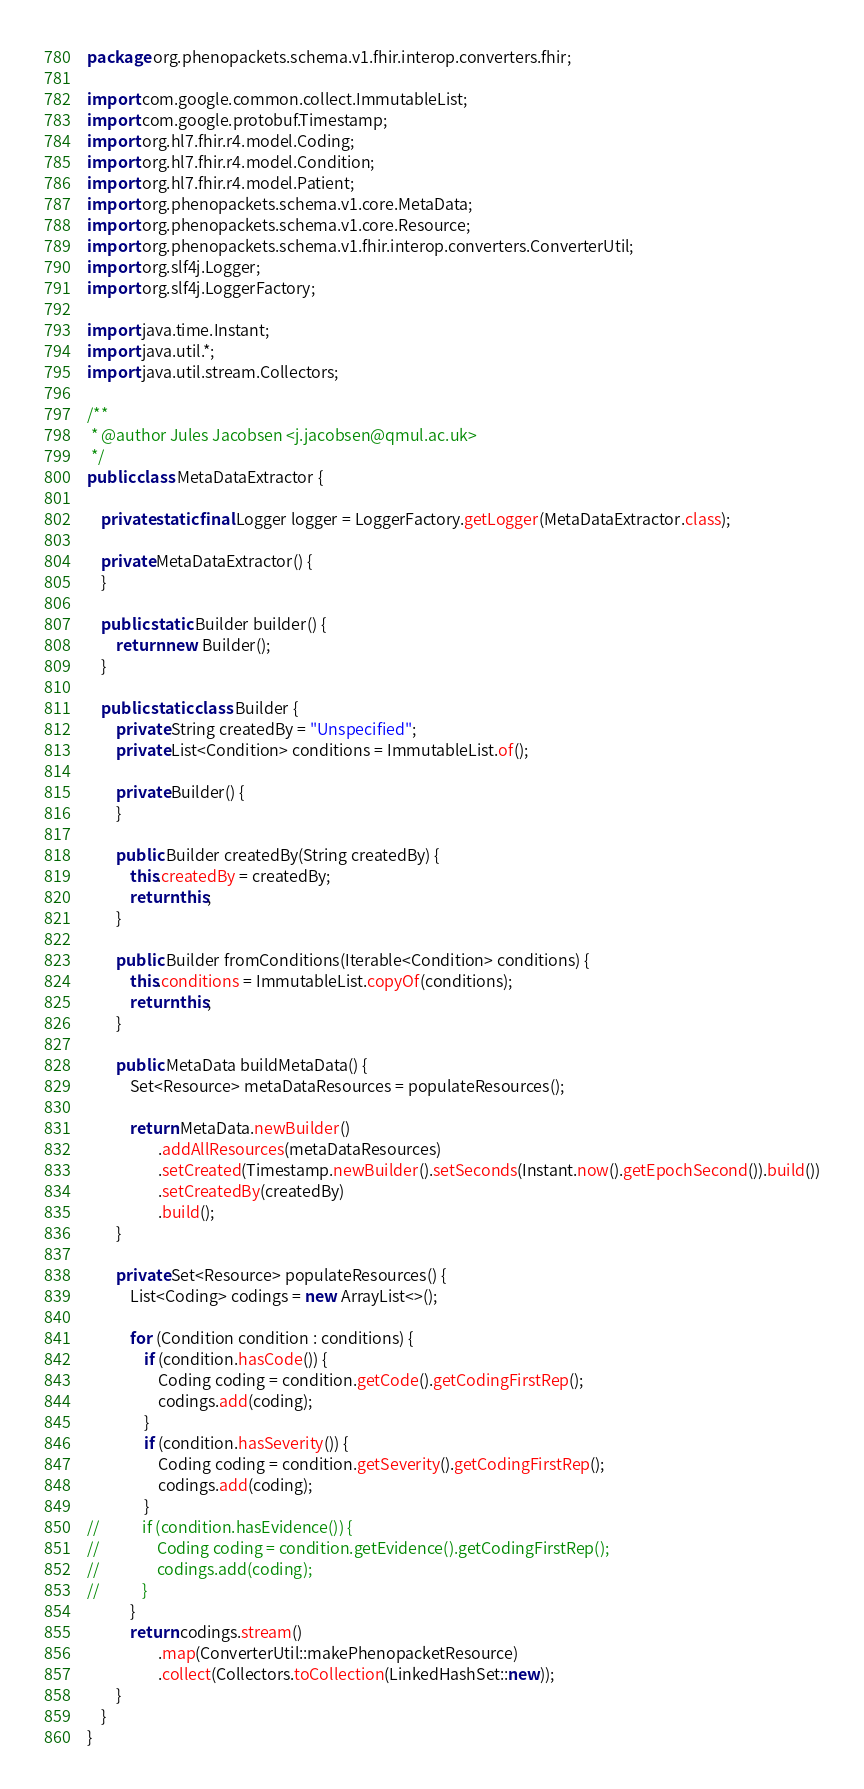<code> <loc_0><loc_0><loc_500><loc_500><_Java_>package org.phenopackets.schema.v1.fhir.interop.converters.fhir;

import com.google.common.collect.ImmutableList;
import com.google.protobuf.Timestamp;
import org.hl7.fhir.r4.model.Coding;
import org.hl7.fhir.r4.model.Condition;
import org.hl7.fhir.r4.model.Patient;
import org.phenopackets.schema.v1.core.MetaData;
import org.phenopackets.schema.v1.core.Resource;
import org.phenopackets.schema.v1.fhir.interop.converters.ConverterUtil;
import org.slf4j.Logger;
import org.slf4j.LoggerFactory;

import java.time.Instant;
import java.util.*;
import java.util.stream.Collectors;

/**
 * @author Jules Jacobsen <j.jacobsen@qmul.ac.uk>
 */
public class MetaDataExtractor {

    private static final Logger logger = LoggerFactory.getLogger(MetaDataExtractor.class);

    private MetaDataExtractor() {
    }

    public static Builder builder() {
        return new Builder();
    }

    public static class Builder {
        private String createdBy = "Unspecified";
        private List<Condition> conditions = ImmutableList.of();

        private Builder() {
        }

        public Builder createdBy(String createdBy) {
            this.createdBy = createdBy;
            return this;
        }

        public Builder fromConditions(Iterable<Condition> conditions) {
            this.conditions = ImmutableList.copyOf(conditions);
            return this;
        }

        public MetaData buildMetaData() {
            Set<Resource> metaDataResources = populateResources();

            return MetaData.newBuilder()
                    .addAllResources(metaDataResources)
                    .setCreated(Timestamp.newBuilder().setSeconds(Instant.now().getEpochSecond()).build())
                    .setCreatedBy(createdBy)
                    .build();
        }

        private Set<Resource> populateResources() {
            List<Coding> codings = new ArrayList<>();

            for (Condition condition : conditions) {
                if (condition.hasCode()) {
                    Coding coding = condition.getCode().getCodingFirstRep();
                    codings.add(coding);
                }
                if (condition.hasSeverity()) {
                    Coding coding = condition.getSeverity().getCodingFirstRep();
                    codings.add(coding);
                }
//            if (condition.hasEvidence()) {
//                Coding coding = condition.getEvidence().getCodingFirstRep();
//                codings.add(coding);
//            }
            }
            return codings.stream()
                    .map(ConverterUtil::makePhenopacketResource)
                    .collect(Collectors.toCollection(LinkedHashSet::new));
        }
    }
}
</code> 